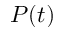<formula> <loc_0><loc_0><loc_500><loc_500>P ( t )</formula> 